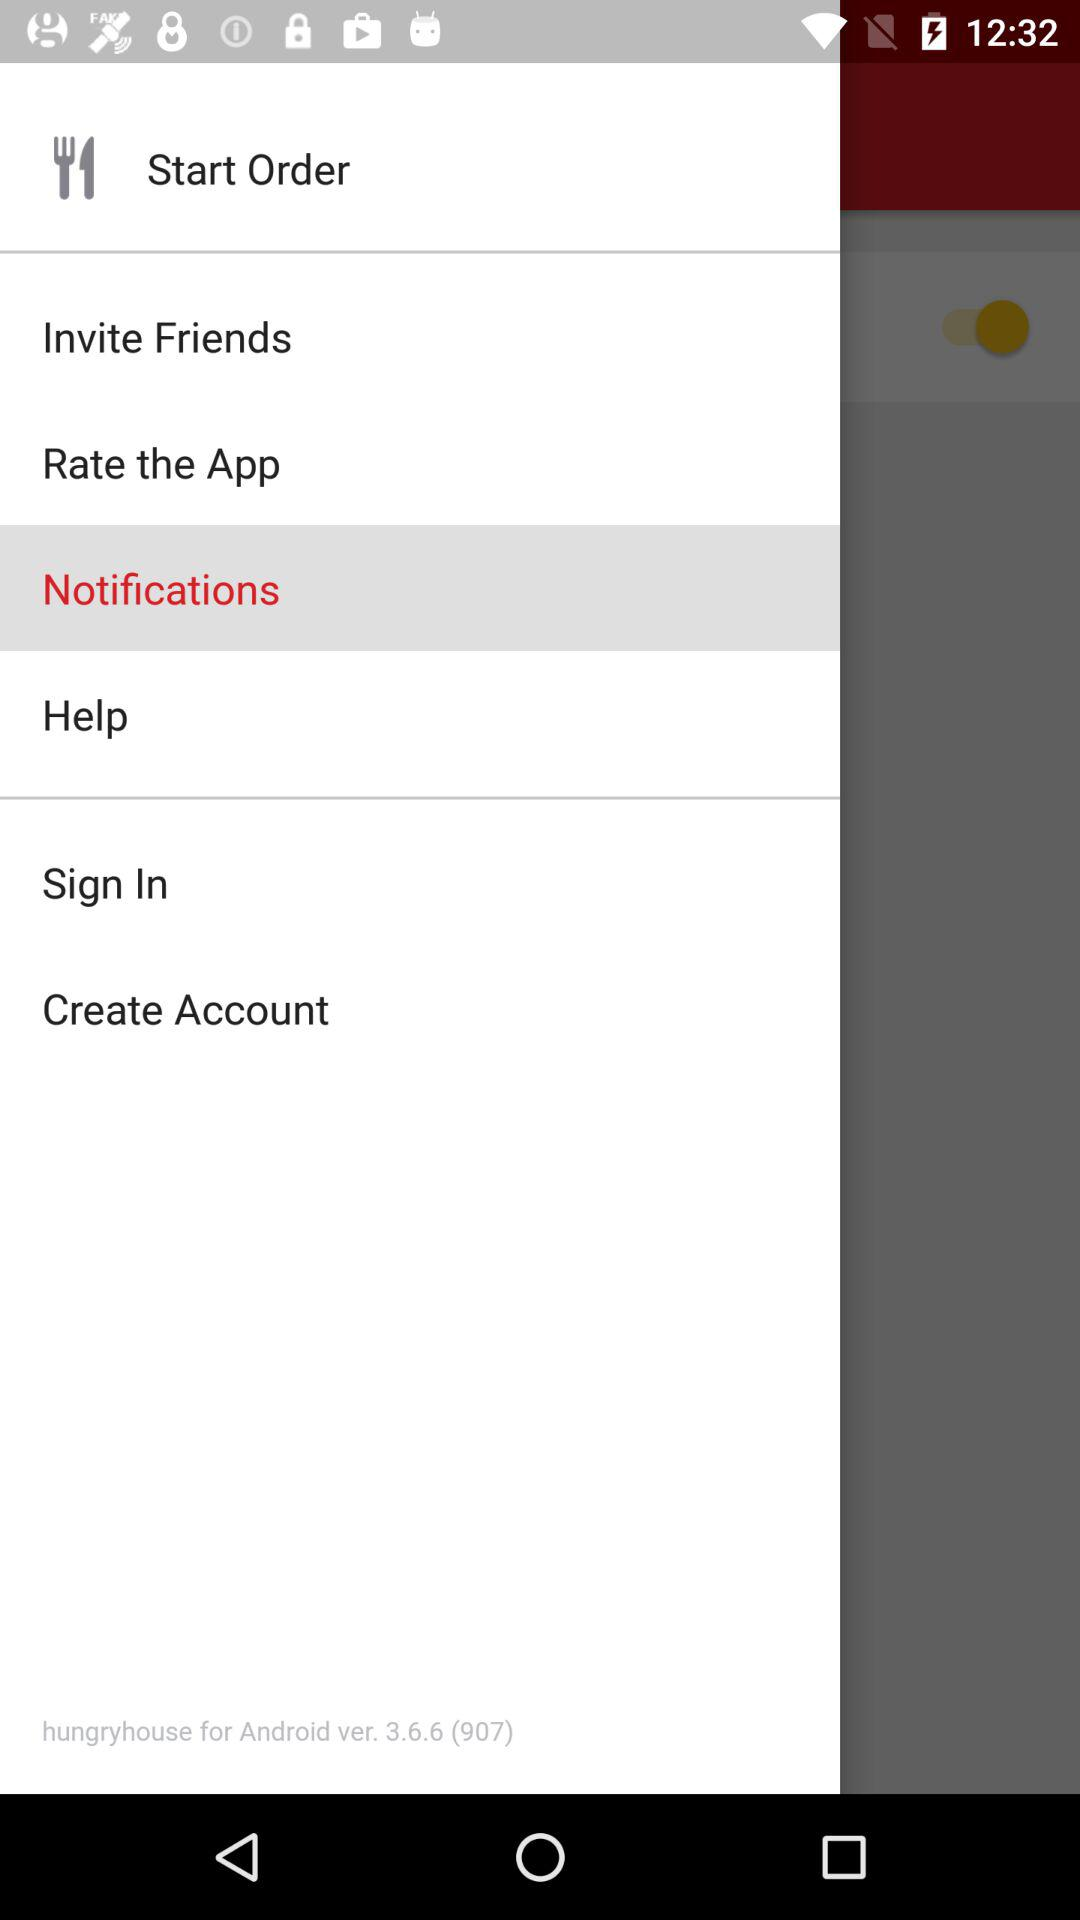What is the version of the application? The version of the application is 3.6.6 (907). 